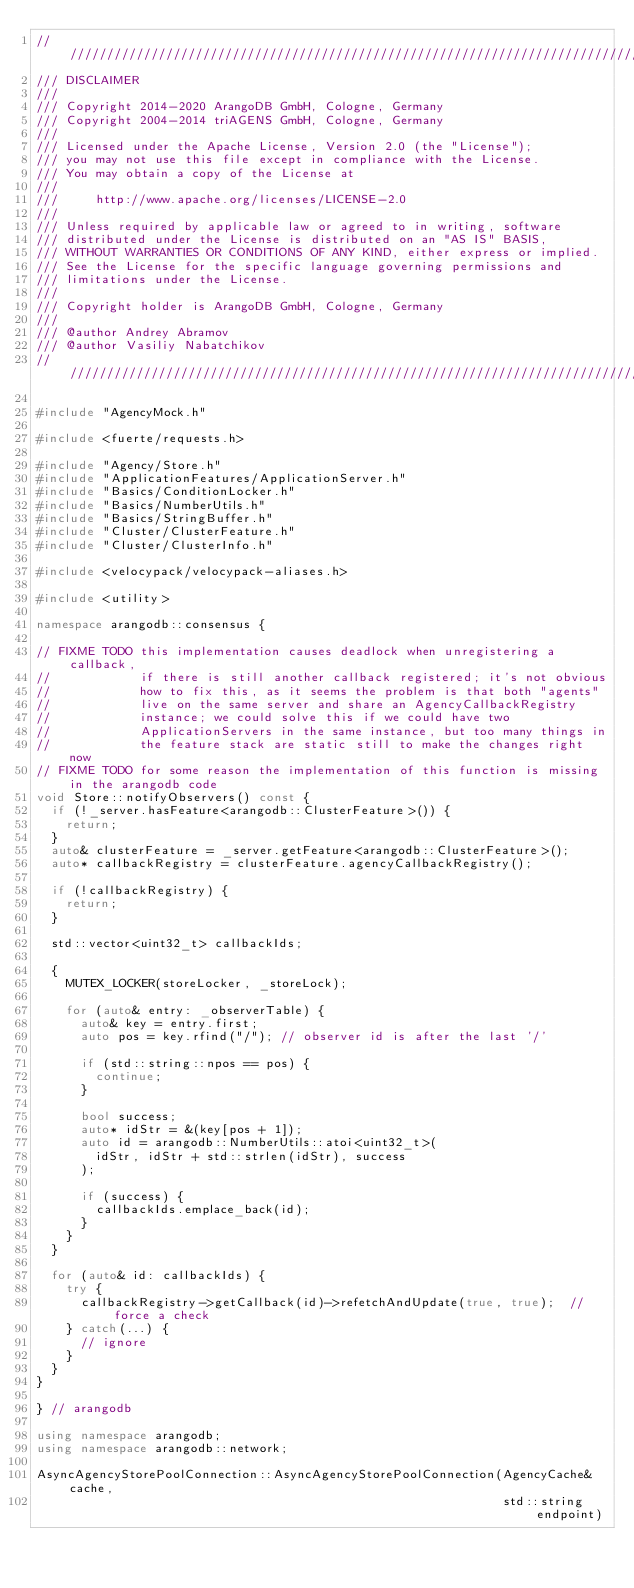<code> <loc_0><loc_0><loc_500><loc_500><_C++_>////////////////////////////////////////////////////////////////////////////////
/// DISCLAIMER
///
/// Copyright 2014-2020 ArangoDB GmbH, Cologne, Germany
/// Copyright 2004-2014 triAGENS GmbH, Cologne, Germany
///
/// Licensed under the Apache License, Version 2.0 (the "License");
/// you may not use this file except in compliance with the License.
/// You may obtain a copy of the License at
///
///     http://www.apache.org/licenses/LICENSE-2.0
///
/// Unless required by applicable law or agreed to in writing, software
/// distributed under the License is distributed on an "AS IS" BASIS,
/// WITHOUT WARRANTIES OR CONDITIONS OF ANY KIND, either express or implied.
/// See the License for the specific language governing permissions and
/// limitations under the License.
///
/// Copyright holder is ArangoDB GmbH, Cologne, Germany
///
/// @author Andrey Abramov
/// @author Vasiliy Nabatchikov
////////////////////////////////////////////////////////////////////////////////

#include "AgencyMock.h"

#include <fuerte/requests.h>

#include "Agency/Store.h"
#include "ApplicationFeatures/ApplicationServer.h"
#include "Basics/ConditionLocker.h"
#include "Basics/NumberUtils.h"
#include "Basics/StringBuffer.h"
#include "Cluster/ClusterFeature.h"
#include "Cluster/ClusterInfo.h"

#include <velocypack/velocypack-aliases.h>

#include <utility>

namespace arangodb::consensus {

// FIXME TODO this implementation causes deadlock when unregistering a callback,
//            if there is still another callback registered; it's not obvious
//            how to fix this, as it seems the problem is that both "agents"
//            live on the same server and share an AgencyCallbackRegistry
//            instance; we could solve this if we could have two
//            ApplicationServers in the same instance, but too many things in
//            the feature stack are static still to make the changes right now
// FIXME TODO for some reason the implementation of this function is missing in the arangodb code
void Store::notifyObservers() const {
  if (!_server.hasFeature<arangodb::ClusterFeature>()) {
    return;
  }
  auto& clusterFeature = _server.getFeature<arangodb::ClusterFeature>();
  auto* callbackRegistry = clusterFeature.agencyCallbackRegistry();

  if (!callbackRegistry) {
    return;
  }

  std::vector<uint32_t> callbackIds;

  {
    MUTEX_LOCKER(storeLocker, _storeLock);

    for (auto& entry: _observerTable) {
      auto& key = entry.first;
      auto pos = key.rfind("/"); // observer id is after the last '/'

      if (std::string::npos == pos) {
        continue;
      }

      bool success;
      auto* idStr = &(key[pos + 1]);
      auto id = arangodb::NumberUtils::atoi<uint32_t>(
        idStr, idStr + std::strlen(idStr), success
      );

      if (success) {
        callbackIds.emplace_back(id);
      }
    }
  }

  for (auto& id: callbackIds) {
    try {
      callbackRegistry->getCallback(id)->refetchAndUpdate(true, true);  // force a check
    } catch(...) {
      // ignore
    }
  }
}

} // arangodb

using namespace arangodb;
using namespace arangodb::network;

AsyncAgencyStorePoolConnection::AsyncAgencyStorePoolConnection(AgencyCache& cache,
                                                               std::string endpoint)</code> 